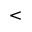Convert formula to latex. <formula><loc_0><loc_0><loc_500><loc_500><</formula> 